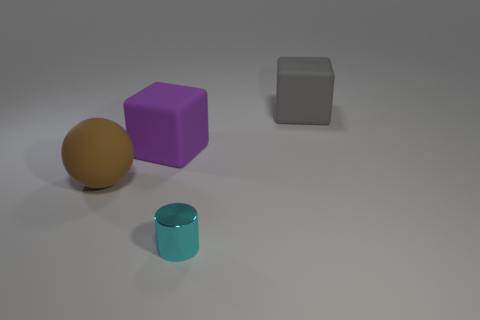There is a metal cylinder that is on the right side of the big matte cube left of the rubber cube that is behind the big purple object; how big is it?
Offer a very short reply. Small. There is a matte block that is left of the large block that is to the right of the small cyan metallic thing; what is its color?
Your answer should be very brief. Purple. What number of other objects are there of the same material as the cylinder?
Give a very brief answer. 0. How many other objects are there of the same color as the tiny cylinder?
Offer a terse response. 0. What is the material of the big cube behind the matte cube that is to the left of the tiny cyan shiny cylinder?
Make the answer very short. Rubber. Are there any small purple metallic cylinders?
Your answer should be compact. No. What size is the cylinder to the right of the big rubber cube that is on the left side of the gray matte cube?
Offer a terse response. Small. Are there more large objects in front of the gray matte cube than big brown spheres right of the purple matte block?
Provide a succinct answer. Yes. What number of cylinders are either big cyan metal objects or big matte things?
Keep it short and to the point. 0. Is there any other thing that has the same size as the cyan cylinder?
Your answer should be compact. No. 